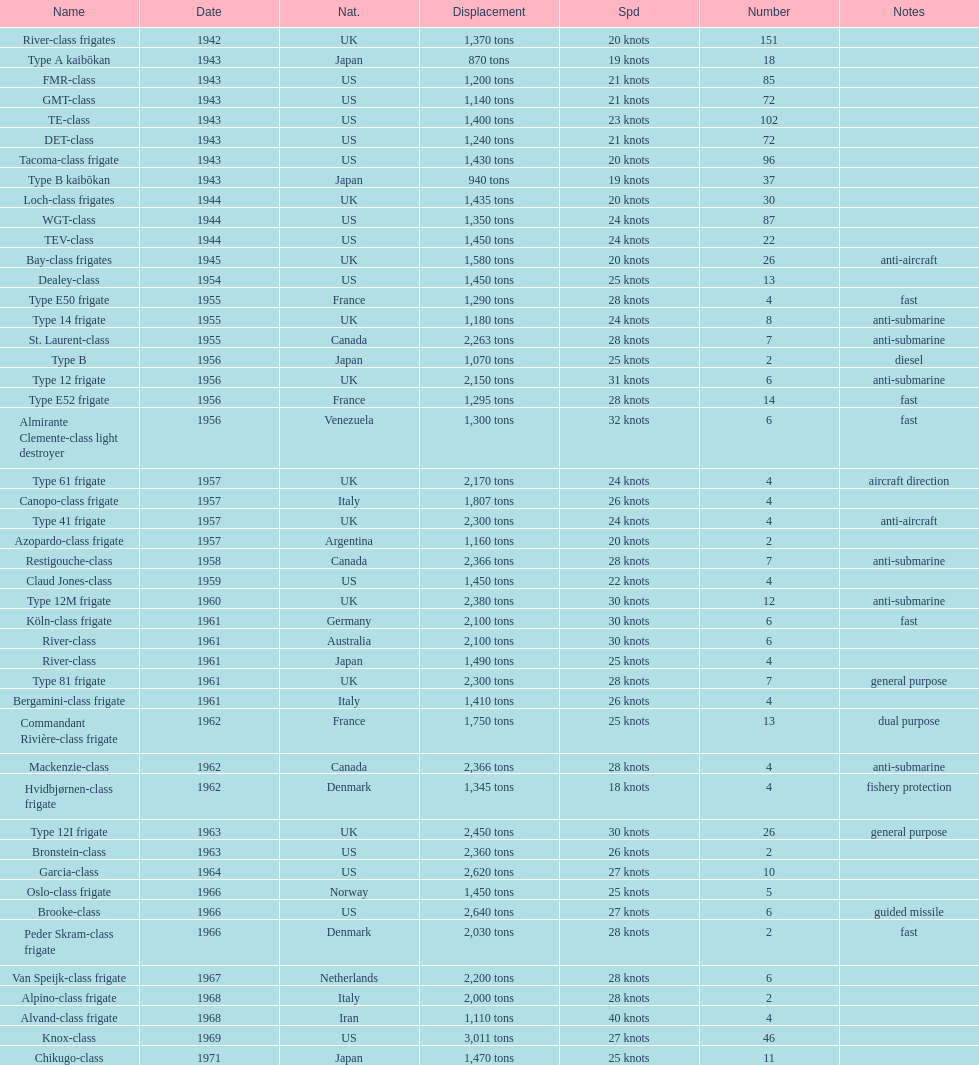How many tons does the te-class displace? 1,400 tons. 